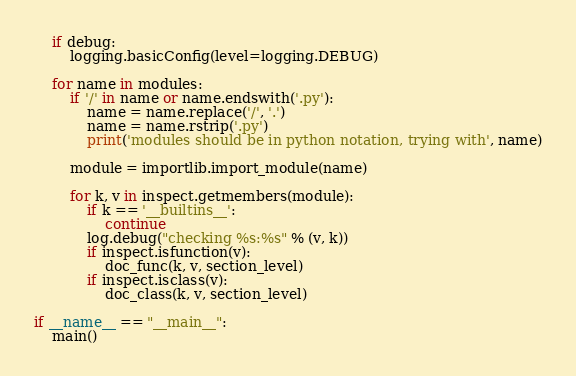<code> <loc_0><loc_0><loc_500><loc_500><_Python_>    if debug:
        logging.basicConfig(level=logging.DEBUG)

    for name in modules:
        if '/' in name or name.endswith('.py'):
            name = name.replace('/', '.')
            name = name.rstrip('.py')
            print('modules should be in python notation, trying with', name)

        module = importlib.import_module(name)

        for k, v in inspect.getmembers(module):
            if k == '__builtins__':
                continue
            log.debug("checking %s:%s" % (v, k))
            if inspect.isfunction(v):
                doc_func(k, v, section_level)
            if inspect.isclass(v):
                doc_class(k, v, section_level)

if __name__ == "__main__":
    main()

</code> 